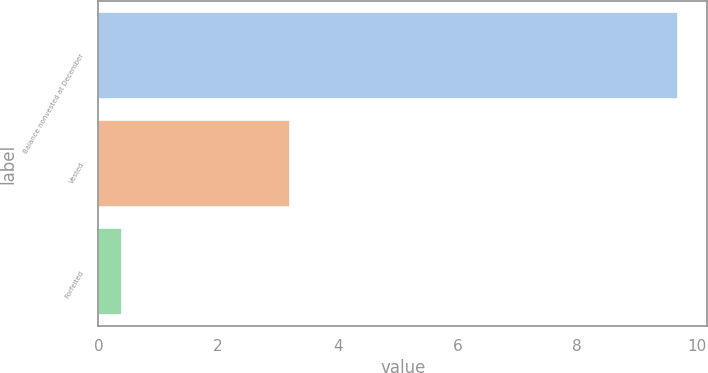<chart> <loc_0><loc_0><loc_500><loc_500><bar_chart><fcel>Balance nonvested at December<fcel>Vested<fcel>Forfeited<nl><fcel>9.69<fcel>3.2<fcel>0.4<nl></chart> 